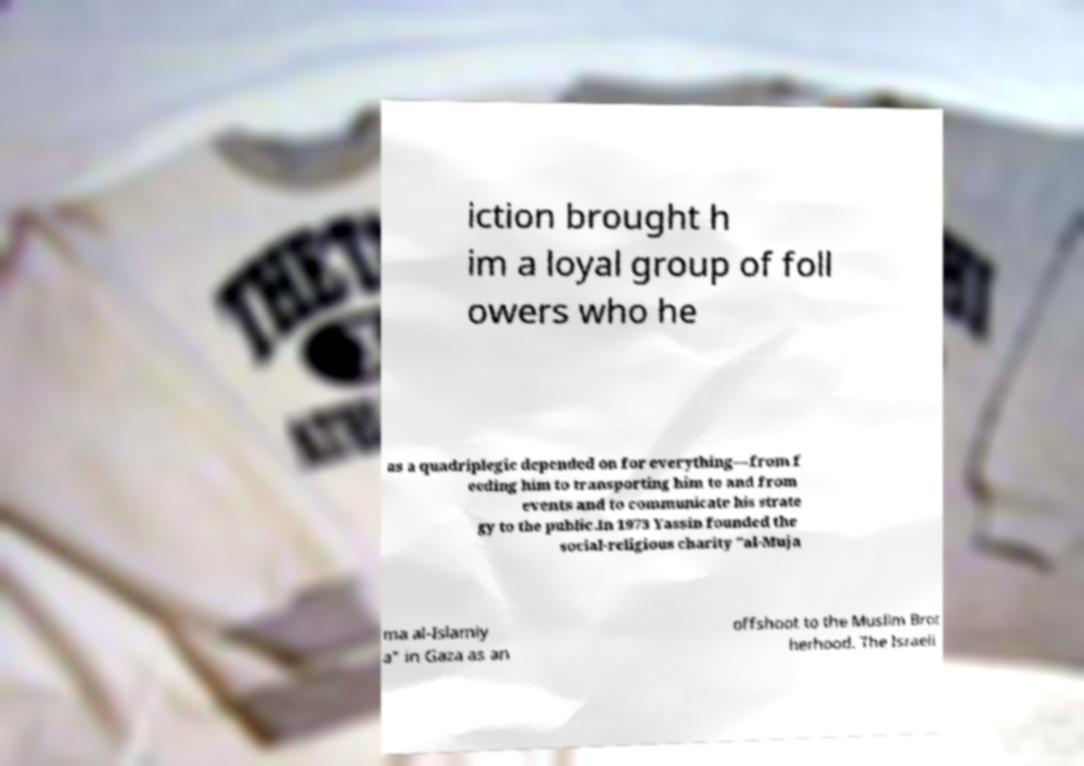Please read and relay the text visible in this image. What does it say? iction brought h im a loyal group of foll owers who he as a quadriplegic depended on for everything—from f eeding him to transporting him to and from events and to communicate his strate gy to the public.In 1973 Yassin founded the social-religious charity "al-Muja ma al-Islamiy a" in Gaza as an offshoot to the Muslim Brot herhood. The Israeli 